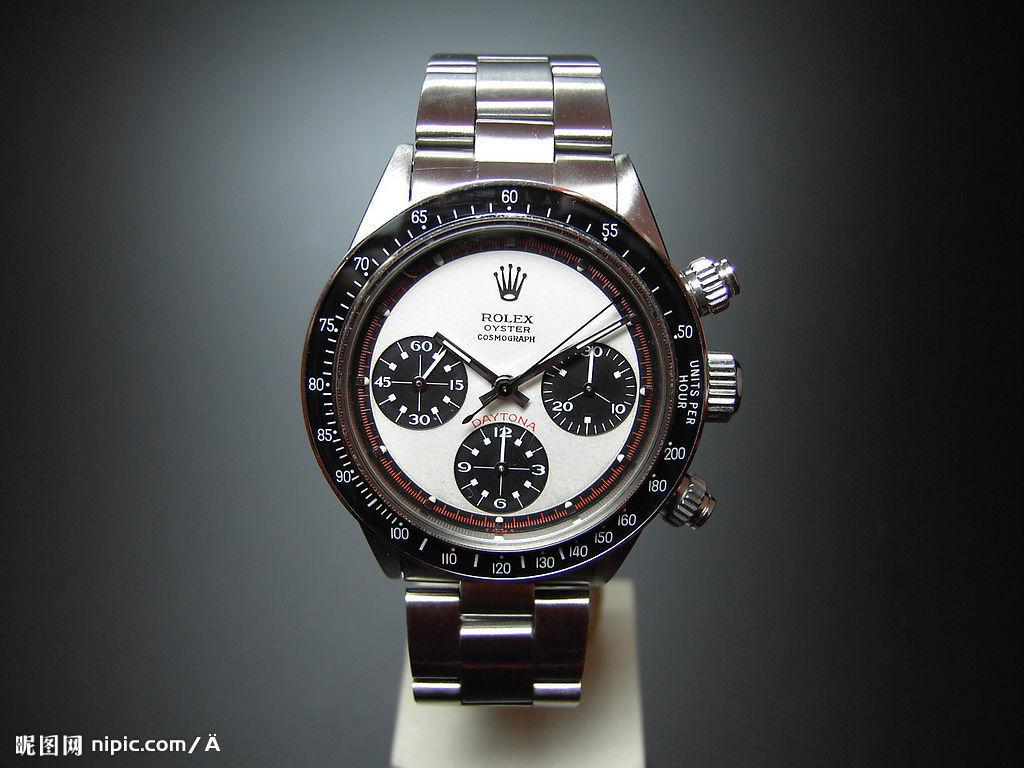<image>
Offer a succinct explanation of the picture presented. Black and silver watch which has the word DAYTONA on the face. 